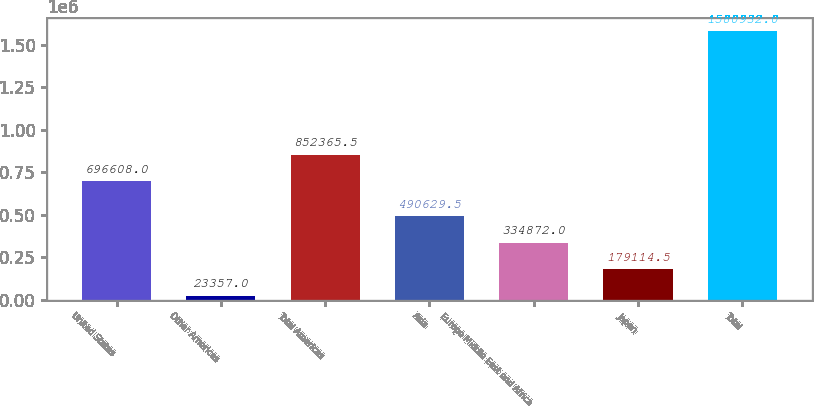Convert chart. <chart><loc_0><loc_0><loc_500><loc_500><bar_chart><fcel>United States<fcel>Other Americas<fcel>Total Americas<fcel>Asia<fcel>Europe Middle East and Africa<fcel>Japan<fcel>Total<nl><fcel>696608<fcel>23357<fcel>852366<fcel>490630<fcel>334872<fcel>179114<fcel>1.58093e+06<nl></chart> 